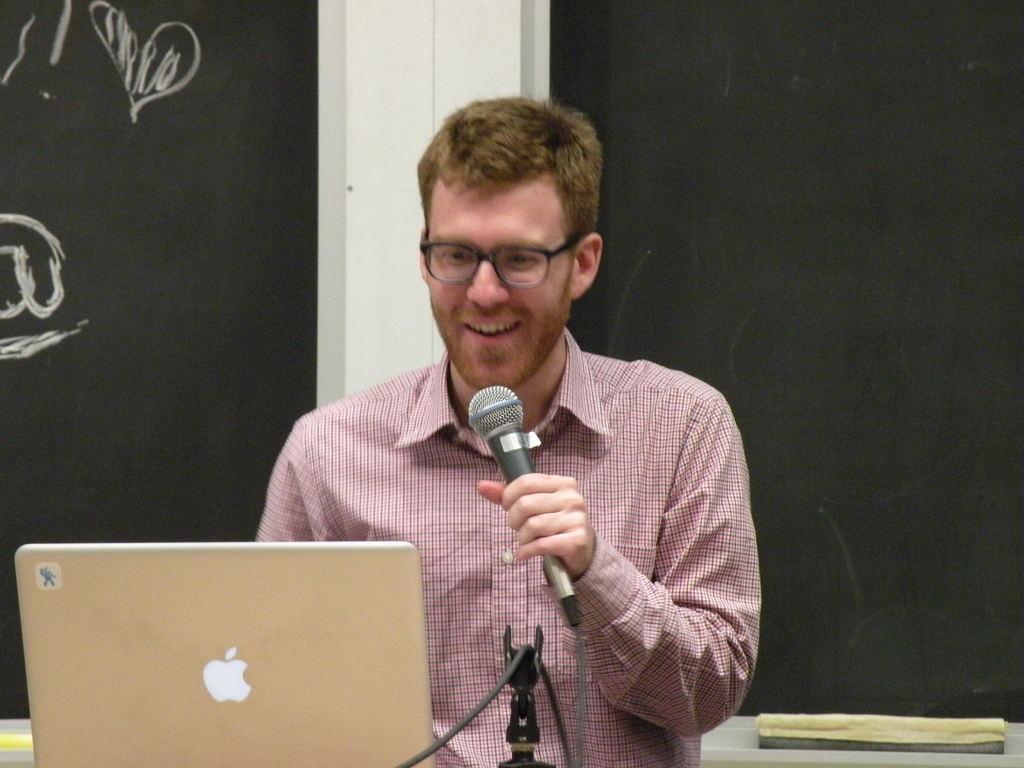In one or two sentences, can you explain what this image depicts? This is a picture of a man, the man is holding the microphone and looking into his laptop. The Background of the person is a blackboard. 